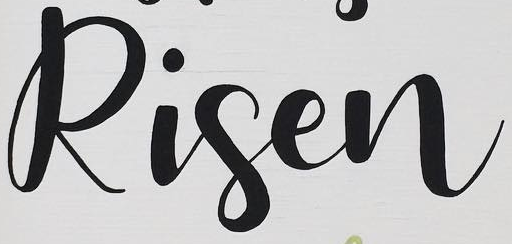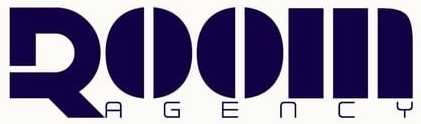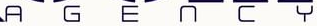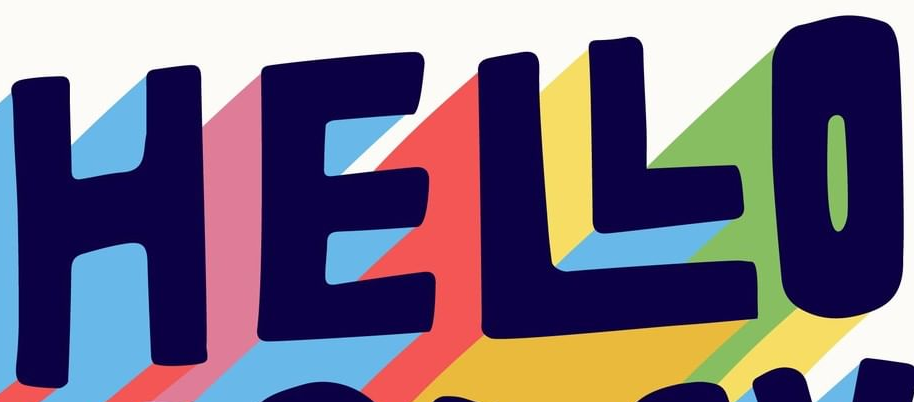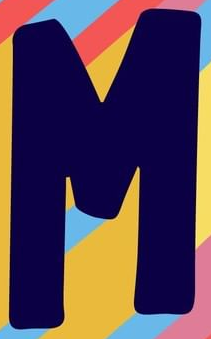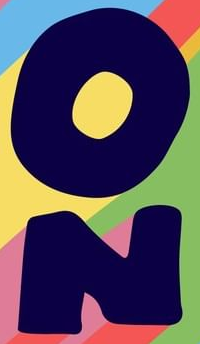Read the text content from these images in order, separated by a semicolon. Risen; ROOM; AGENCY; HELLO; M; ON 